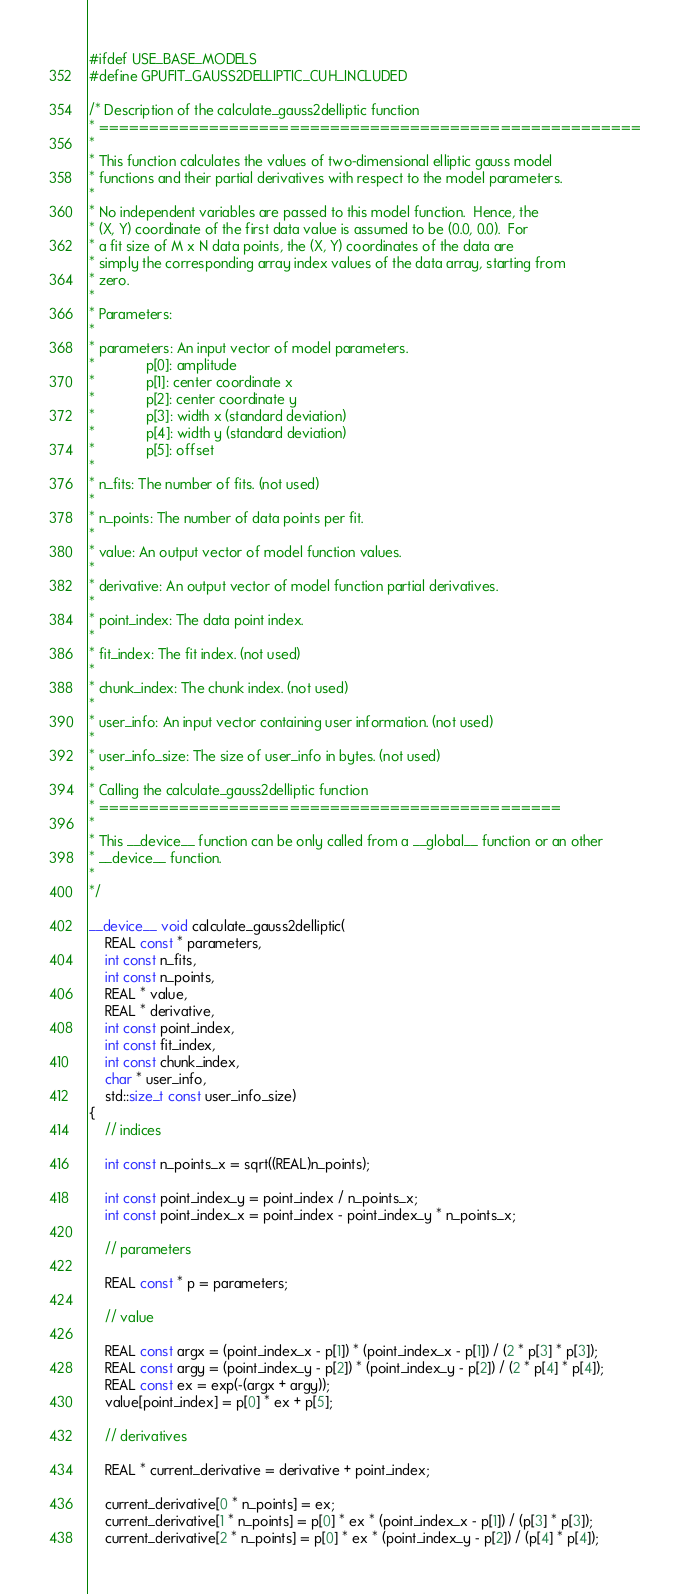Convert code to text. <code><loc_0><loc_0><loc_500><loc_500><_Cuda_>#ifdef USE_BASE_MODELS
#define GPUFIT_GAUSS2DELLIPTIC_CUH_INCLUDED

/* Description of the calculate_gauss2delliptic function
* ======================================================
*
* This function calculates the values of two-dimensional elliptic gauss model
* functions and their partial derivatives with respect to the model parameters.
*
* No independent variables are passed to this model function.  Hence, the 
* (X, Y) coordinate of the first data value is assumed to be (0.0, 0.0).  For
* a fit size of M x N data points, the (X, Y) coordinates of the data are
* simply the corresponding array index values of the data array, starting from
* zero.
*
* Parameters:
*
* parameters: An input vector of model parameters.
*             p[0]: amplitude
*             p[1]: center coordinate x
*             p[2]: center coordinate y
*             p[3]: width x (standard deviation)
*             p[4]: width y (standard deviation)
*             p[5]: offset
*
* n_fits: The number of fits. (not used)
*
* n_points: The number of data points per fit.
*
* value: An output vector of model function values.
*
* derivative: An output vector of model function partial derivatives.
*
* point_index: The data point index.
*
* fit_index: The fit index. (not used)
*
* chunk_index: The chunk index. (not used)
*
* user_info: An input vector containing user information. (not used)
*
* user_info_size: The size of user_info in bytes. (not used)
*
* Calling the calculate_gauss2delliptic function
* ==============================================
*
* This __device__ function can be only called from a __global__ function or an other
* __device__ function.
*
*/

__device__ void calculate_gauss2delliptic(
    REAL const * parameters,
    int const n_fits,
    int const n_points,
    REAL * value,
    REAL * derivative,
    int const point_index,
    int const fit_index,
    int const chunk_index,
    char * user_info,
    std::size_t const user_info_size)
{
    // indices

    int const n_points_x = sqrt((REAL)n_points);

    int const point_index_y = point_index / n_points_x;
    int const point_index_x = point_index - point_index_y * n_points_x;

    // parameters

    REAL const * p = parameters;

    // value

    REAL const argx = (point_index_x - p[1]) * (point_index_x - p[1]) / (2 * p[3] * p[3]);
    REAL const argy = (point_index_y - p[2]) * (point_index_y - p[2]) / (2 * p[4] * p[4]);
    REAL const ex = exp(-(argx + argy));
    value[point_index] = p[0] * ex + p[5];

    // derivatives

    REAL * current_derivative = derivative + point_index;

    current_derivative[0 * n_points] = ex;
    current_derivative[1 * n_points] = p[0] * ex * (point_index_x - p[1]) / (p[3] * p[3]);
    current_derivative[2 * n_points] = p[0] * ex * (point_index_y - p[2]) / (p[4] * p[4]);</code> 